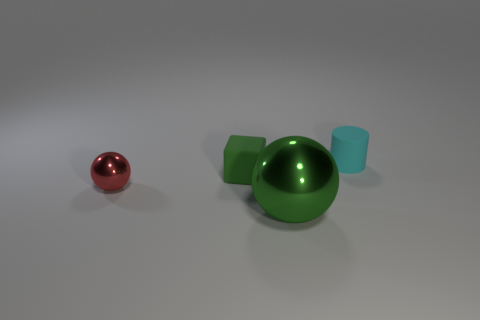There is another matte object that is the same color as the large object; what is its shape?
Provide a succinct answer. Cube. There is a object that is both right of the rubber block and behind the red object; what material is it?
Your answer should be compact. Rubber. There is a small shiny object; does it have the same shape as the tiny object that is behind the matte cube?
Offer a very short reply. No. What number of other things are there of the same size as the green ball?
Make the answer very short. 0. Are there more tiny green rubber cubes than yellow things?
Ensure brevity in your answer.  Yes. What number of things are both to the right of the small green matte thing and behind the red metallic ball?
Offer a very short reply. 1. What shape is the rubber thing to the left of the green object in front of the tiny sphere behind the green metallic sphere?
Your answer should be compact. Cube. Is there anything else that is the same shape as the tiny cyan thing?
Offer a very short reply. No. What number of cylinders are tiny rubber objects or shiny objects?
Your answer should be compact. 1. There is a shiny ball to the right of the small metal thing; is it the same color as the tiny ball?
Provide a short and direct response. No. 